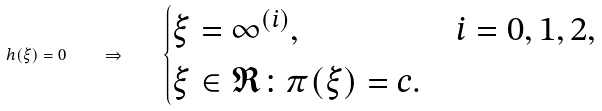<formula> <loc_0><loc_0><loc_500><loc_500>h ( \xi ) = 0 \quad \Rightarrow \quad \begin{cases} \xi = \infty ^ { ( i ) } , & i = 0 , 1 , 2 , \\ \xi \in \mathfrak { R } \colon \pi ( \xi ) = c . \end{cases}</formula> 